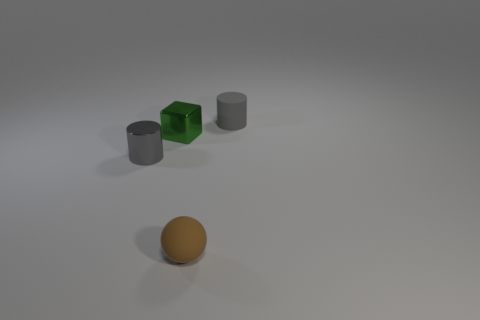Add 4 small gray shiny cylinders. How many objects exist? 8 Subtract all spheres. How many objects are left? 3 Subtract 0 green balls. How many objects are left? 4 Subtract all small yellow cubes. Subtract all tiny gray metal cylinders. How many objects are left? 3 Add 3 tiny balls. How many tiny balls are left? 4 Add 3 metal cylinders. How many metal cylinders exist? 4 